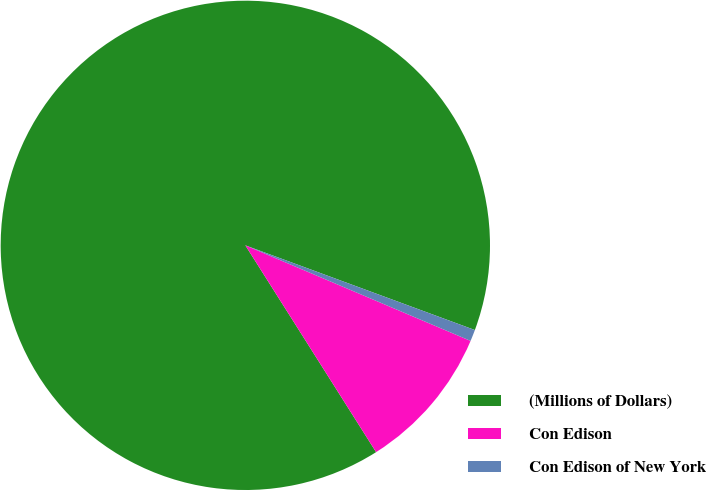Convert chart. <chart><loc_0><loc_0><loc_500><loc_500><pie_chart><fcel>(Millions of Dollars)<fcel>Con Edison<fcel>Con Edison of New York<nl><fcel>89.6%<fcel>9.64%<fcel>0.76%<nl></chart> 